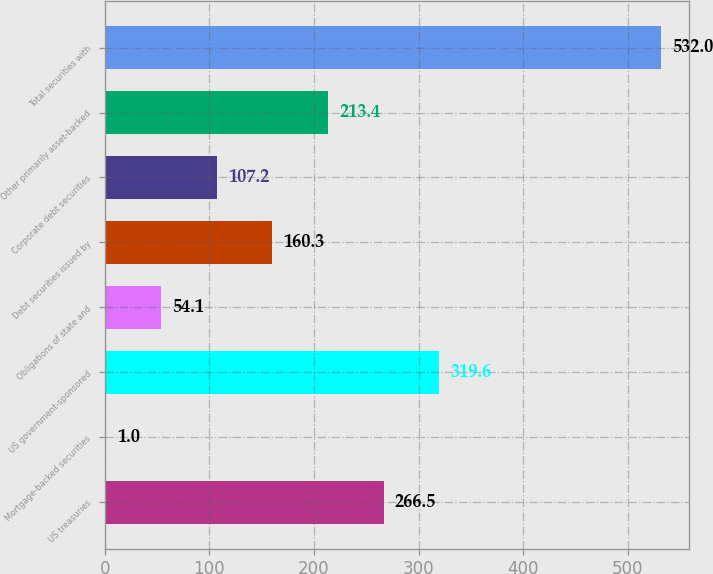Convert chart. <chart><loc_0><loc_0><loc_500><loc_500><bar_chart><fcel>US treasuries<fcel>Mortgage-backed securities<fcel>US government-sponsored<fcel>Obligations of state and<fcel>Debt securities issued by<fcel>Corporate debt securities<fcel>Other primarily asset-backed<fcel>Total securities with<nl><fcel>266.5<fcel>1<fcel>319.6<fcel>54.1<fcel>160.3<fcel>107.2<fcel>213.4<fcel>532<nl></chart> 